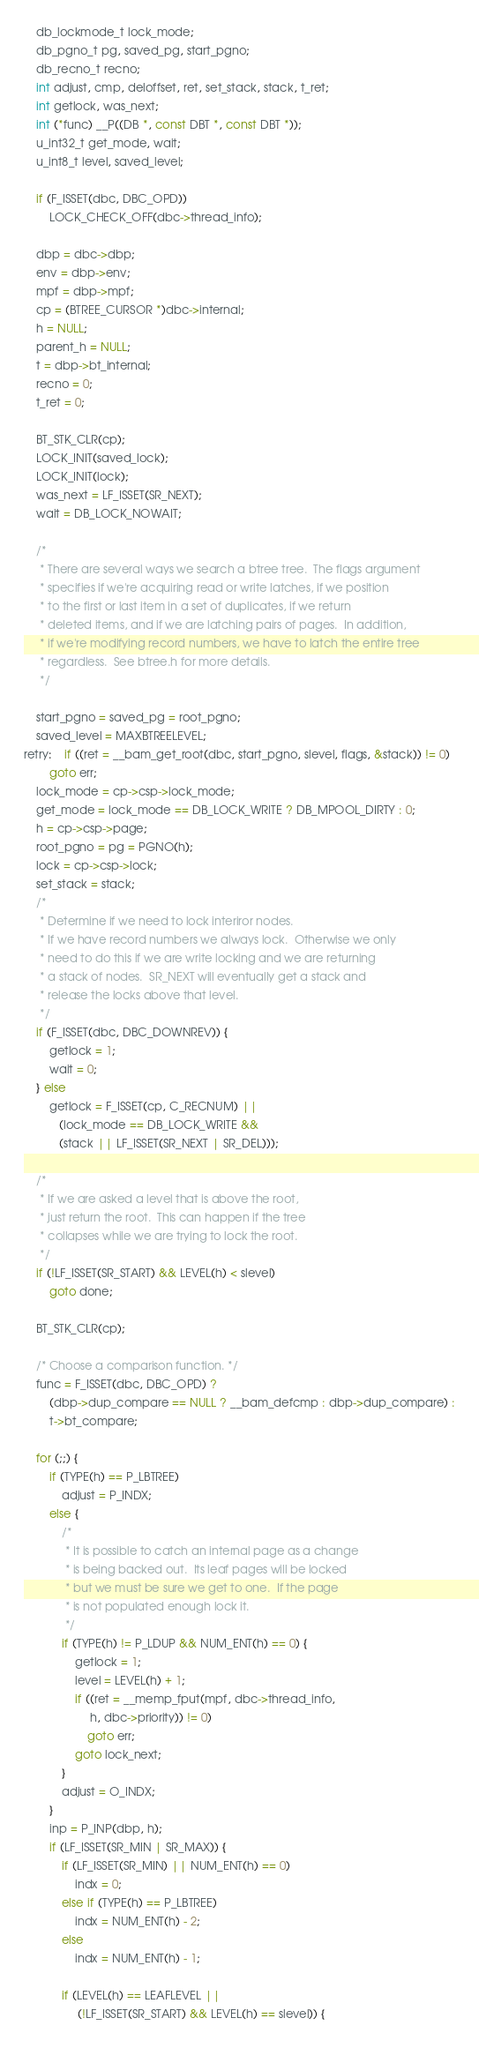Convert code to text. <code><loc_0><loc_0><loc_500><loc_500><_C_>	db_lockmode_t lock_mode;
	db_pgno_t pg, saved_pg, start_pgno;
	db_recno_t recno;
	int adjust, cmp, deloffset, ret, set_stack, stack, t_ret;
	int getlock, was_next;
	int (*func) __P((DB *, const DBT *, const DBT *));
	u_int32_t get_mode, wait;
	u_int8_t level, saved_level;

	if (F_ISSET(dbc, DBC_OPD))
		LOCK_CHECK_OFF(dbc->thread_info);

	dbp = dbc->dbp;
	env = dbp->env;
	mpf = dbp->mpf;
	cp = (BTREE_CURSOR *)dbc->internal;
	h = NULL;
	parent_h = NULL;
	t = dbp->bt_internal;
	recno = 0;
	t_ret = 0;

	BT_STK_CLR(cp);
	LOCK_INIT(saved_lock);
	LOCK_INIT(lock);
	was_next = LF_ISSET(SR_NEXT);
	wait = DB_LOCK_NOWAIT;

	/*
	 * There are several ways we search a btree tree.  The flags argument
	 * specifies if we're acquiring read or write latches, if we position
	 * to the first or last item in a set of duplicates, if we return
	 * deleted items, and if we are latching pairs of pages.  In addition,
	 * if we're modifying record numbers, we have to latch the entire tree
	 * regardless.  See btree.h for more details.
	 */

	start_pgno = saved_pg = root_pgno;
	saved_level = MAXBTREELEVEL;
retry:	if ((ret = __bam_get_root(dbc, start_pgno, slevel, flags, &stack)) != 0)
		goto err;
	lock_mode = cp->csp->lock_mode;
	get_mode = lock_mode == DB_LOCK_WRITE ? DB_MPOOL_DIRTY : 0;
	h = cp->csp->page;
	root_pgno = pg = PGNO(h);
	lock = cp->csp->lock;
	set_stack = stack;
	/*
	 * Determine if we need to lock interiror nodes.
	 * If we have record numbers we always lock.  Otherwise we only
	 * need to do this if we are write locking and we are returning
	 * a stack of nodes.  SR_NEXT will eventually get a stack and
	 * release the locks above that level.
	 */
	if (F_ISSET(dbc, DBC_DOWNREV)) {
		getlock = 1;
		wait = 0;
	} else
		getlock = F_ISSET(cp, C_RECNUM) ||
		   (lock_mode == DB_LOCK_WRITE &&
		   (stack || LF_ISSET(SR_NEXT | SR_DEL)));

	/*
	 * If we are asked a level that is above the root,
	 * just return the root.  This can happen if the tree
	 * collapses while we are trying to lock the root.
	 */
	if (!LF_ISSET(SR_START) && LEVEL(h) < slevel)
		goto done;

	BT_STK_CLR(cp);

	/* Choose a comparison function. */
	func = F_ISSET(dbc, DBC_OPD) ?
	    (dbp->dup_compare == NULL ? __bam_defcmp : dbp->dup_compare) :
	    t->bt_compare;

	for (;;) {
		if (TYPE(h) == P_LBTREE)
			adjust = P_INDX;
		else {
			/*
			 * It is possible to catch an internal page as a change
			 * is being backed out.  Its leaf pages will be locked
			 * but we must be sure we get to one.  If the page
			 * is not populated enough lock it.
			 */
			if (TYPE(h) != P_LDUP && NUM_ENT(h) == 0) {
				getlock = 1;
				level = LEVEL(h) + 1;
				if ((ret = __memp_fput(mpf, dbc->thread_info,
				     h, dbc->priority)) != 0)
					goto err;
				goto lock_next;
			}
			adjust = O_INDX;
		}
		inp = P_INP(dbp, h);
		if (LF_ISSET(SR_MIN | SR_MAX)) {
			if (LF_ISSET(SR_MIN) || NUM_ENT(h) == 0)
				indx = 0;
			else if (TYPE(h) == P_LBTREE)
				indx = NUM_ENT(h) - 2;
			else
				indx = NUM_ENT(h) - 1;

			if (LEVEL(h) == LEAFLEVEL ||
			     (!LF_ISSET(SR_START) && LEVEL(h) == slevel)) {</code> 